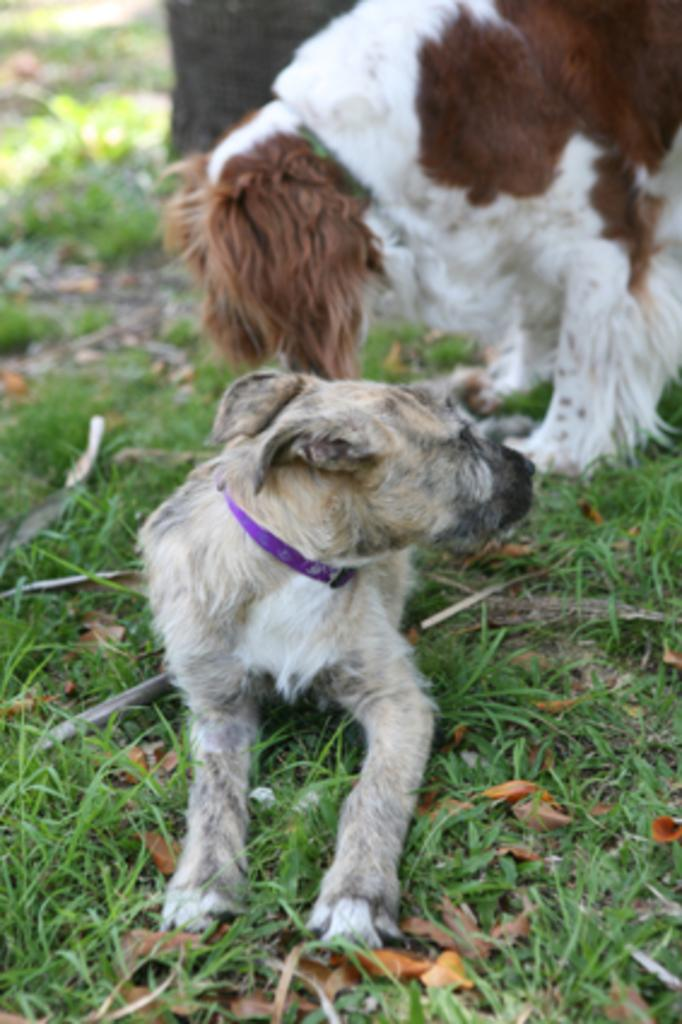What is the main subject in the foreground of the image? There are two dogs in the foreground of the image, one sitting and one standing. Can you describe the position of the dogs in the image? The sitting dog is in the front, while the standing dog is behind it. What can be seen in the background of the image? There is a tree trunk visible in the background of the image. What type of game is the giraffe playing with the dogs in the image? There is no giraffe present in the image, and therefore no such game can be observed. 